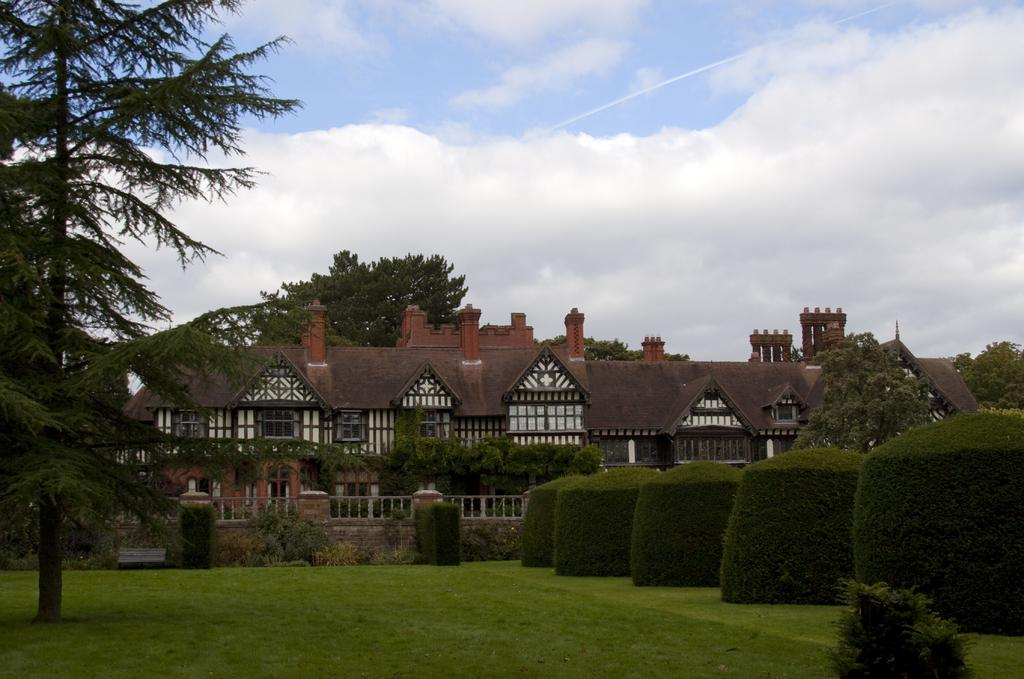What type of structures can be seen in the image? There are buildings in the image. What type of vegetation is present in the image? There are trees, plants, and grass in the image. What type of barrier can be seen in the image? There is a fence in the image. What part of the natural environment is visible in the image? The sky is visible in the background of the image. What type of operation is being performed by the queen in the image? There is no queen or operation present in the image. Can you see any sails in the image? There are no sails visible in the image. 